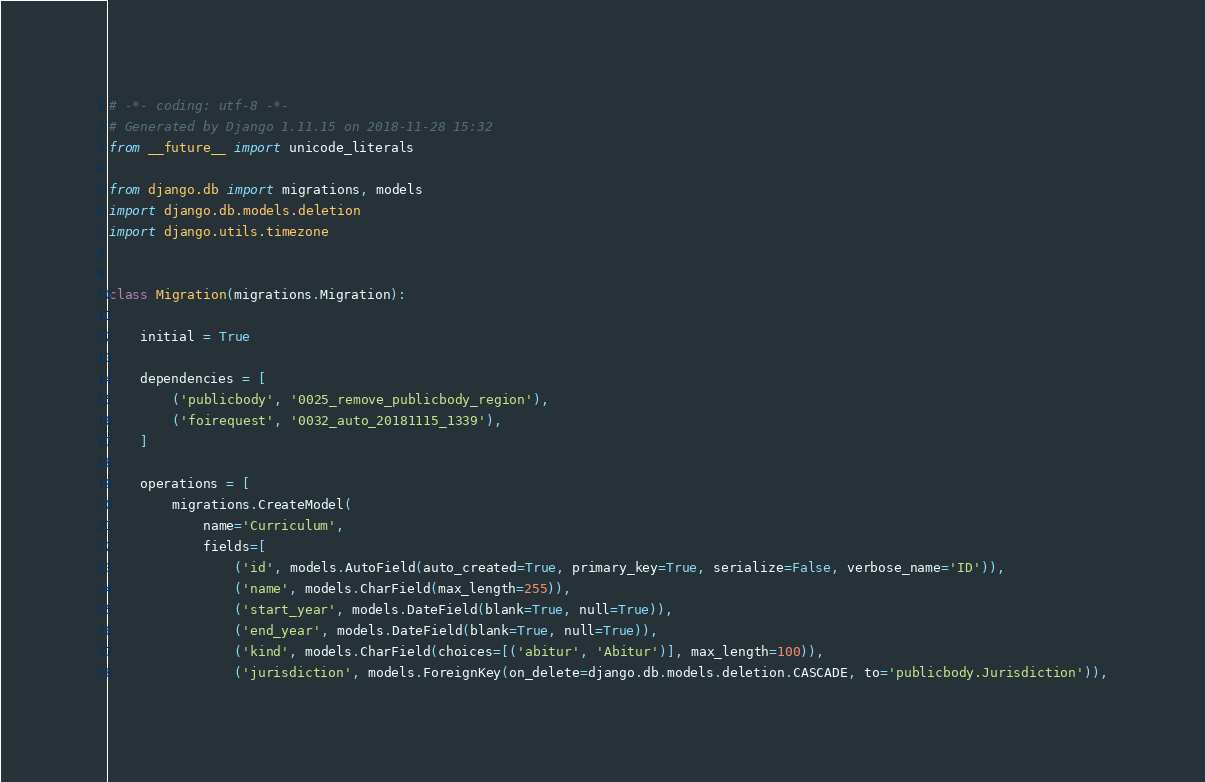Convert code to text. <code><loc_0><loc_0><loc_500><loc_500><_Python_># -*- coding: utf-8 -*-
# Generated by Django 1.11.15 on 2018-11-28 15:32
from __future__ import unicode_literals

from django.db import migrations, models
import django.db.models.deletion
import django.utils.timezone


class Migration(migrations.Migration):

    initial = True

    dependencies = [
        ('publicbody', '0025_remove_publicbody_region'),
        ('foirequest', '0032_auto_20181115_1339'),
    ]

    operations = [
        migrations.CreateModel(
            name='Curriculum',
            fields=[
                ('id', models.AutoField(auto_created=True, primary_key=True, serialize=False, verbose_name='ID')),
                ('name', models.CharField(max_length=255)),
                ('start_year', models.DateField(blank=True, null=True)),
                ('end_year', models.DateField(blank=True, null=True)),
                ('kind', models.CharField(choices=[('abitur', 'Abitur')], max_length=100)),
                ('jurisdiction', models.ForeignKey(on_delete=django.db.models.deletion.CASCADE, to='publicbody.Jurisdiction')),</code> 